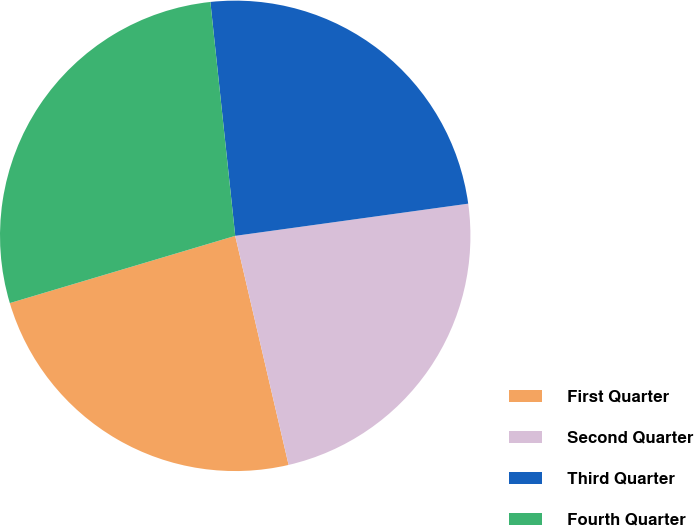Convert chart. <chart><loc_0><loc_0><loc_500><loc_500><pie_chart><fcel>First Quarter<fcel>Second Quarter<fcel>Third Quarter<fcel>Fourth Quarter<nl><fcel>24.03%<fcel>23.54%<fcel>24.5%<fcel>27.93%<nl></chart> 